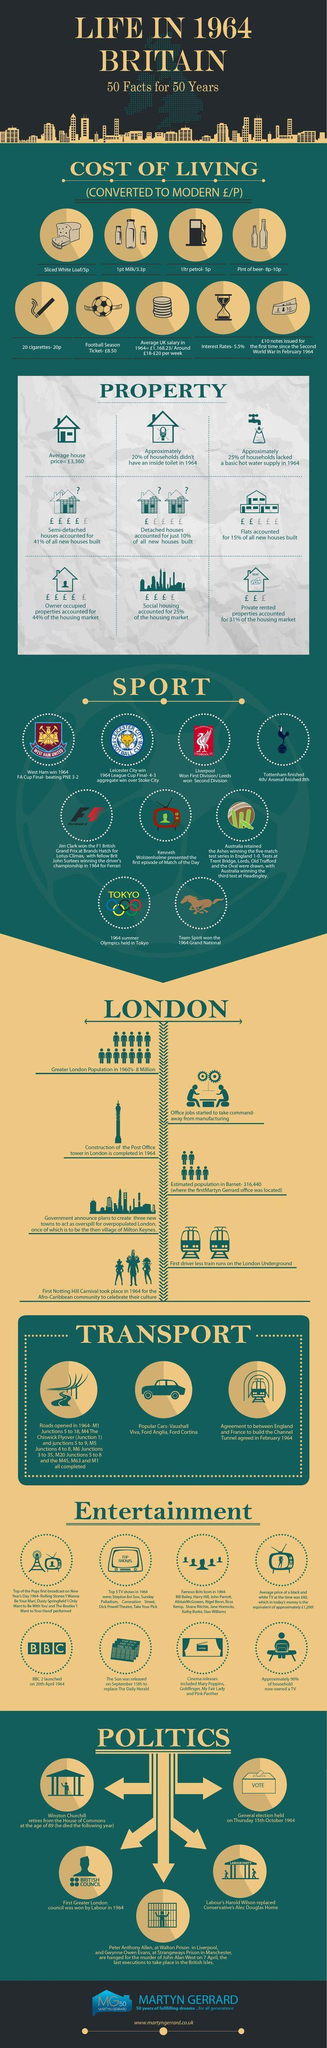Highlight a few significant elements in this photo. In 1964, the average house price in Britain was approximately €3,360. The construction of the Post Office Tower in London was completed in 1964. Winston Churchill retired from The House of Commons at the age of 89. The general elections were held on Thursday, October 15th, 1964. The winner of the FA Cup in the year 1964 was West Ham football club. 